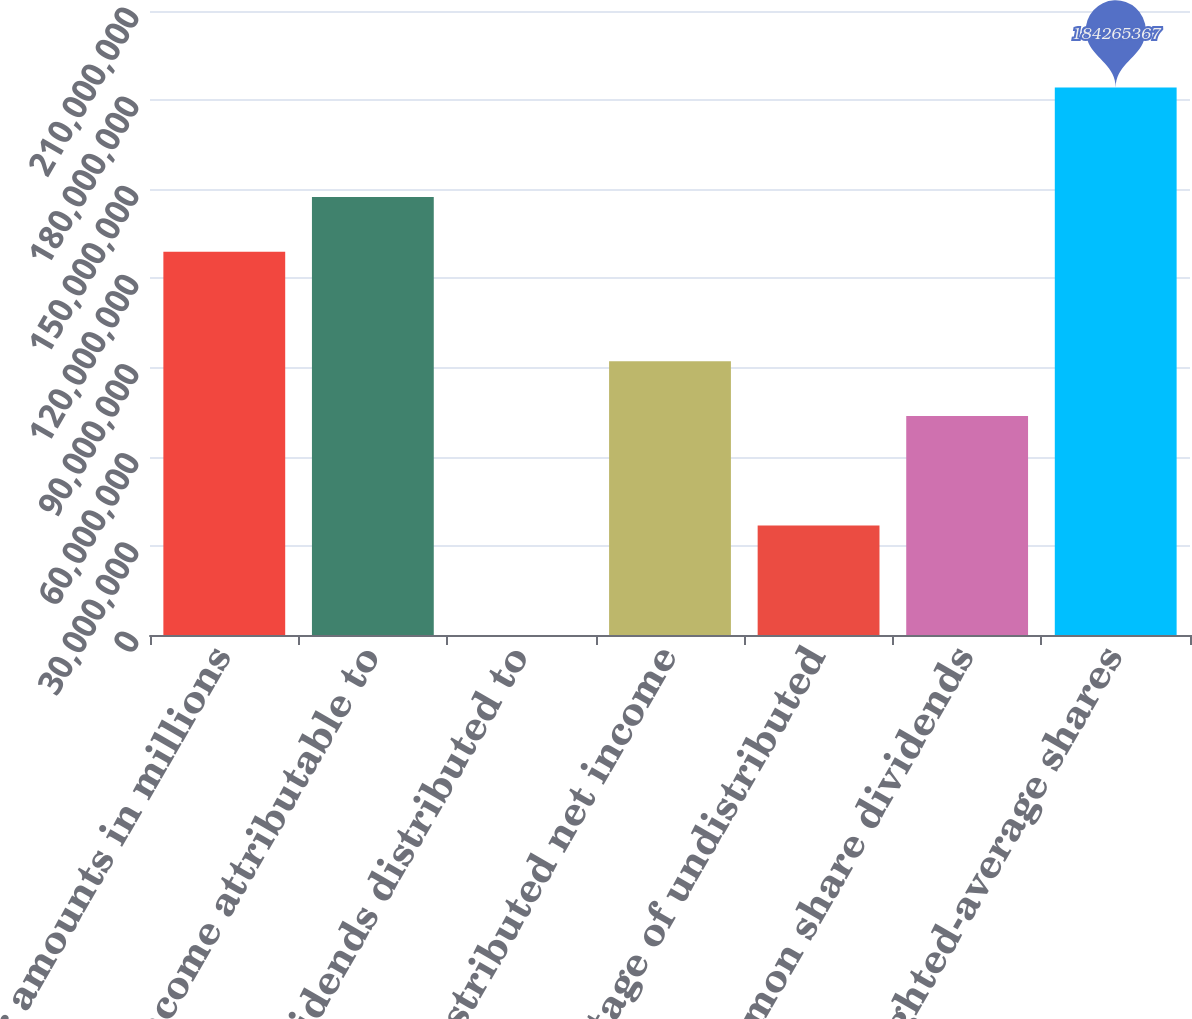Convert chart. <chart><loc_0><loc_0><loc_500><loc_500><bar_chart><fcel>(Dollar amounts in millions<fcel>net income attributable to<fcel>dividends distributed to<fcel>undistributed net income<fcel>percentage of undistributed<fcel>common share dividends<fcel>Weighted-average shares<nl><fcel>1.28986e+08<fcel>1.47412e+08<fcel>10<fcel>9.21327e+07<fcel>3.68531e+07<fcel>7.37062e+07<fcel>1.84265e+08<nl></chart> 